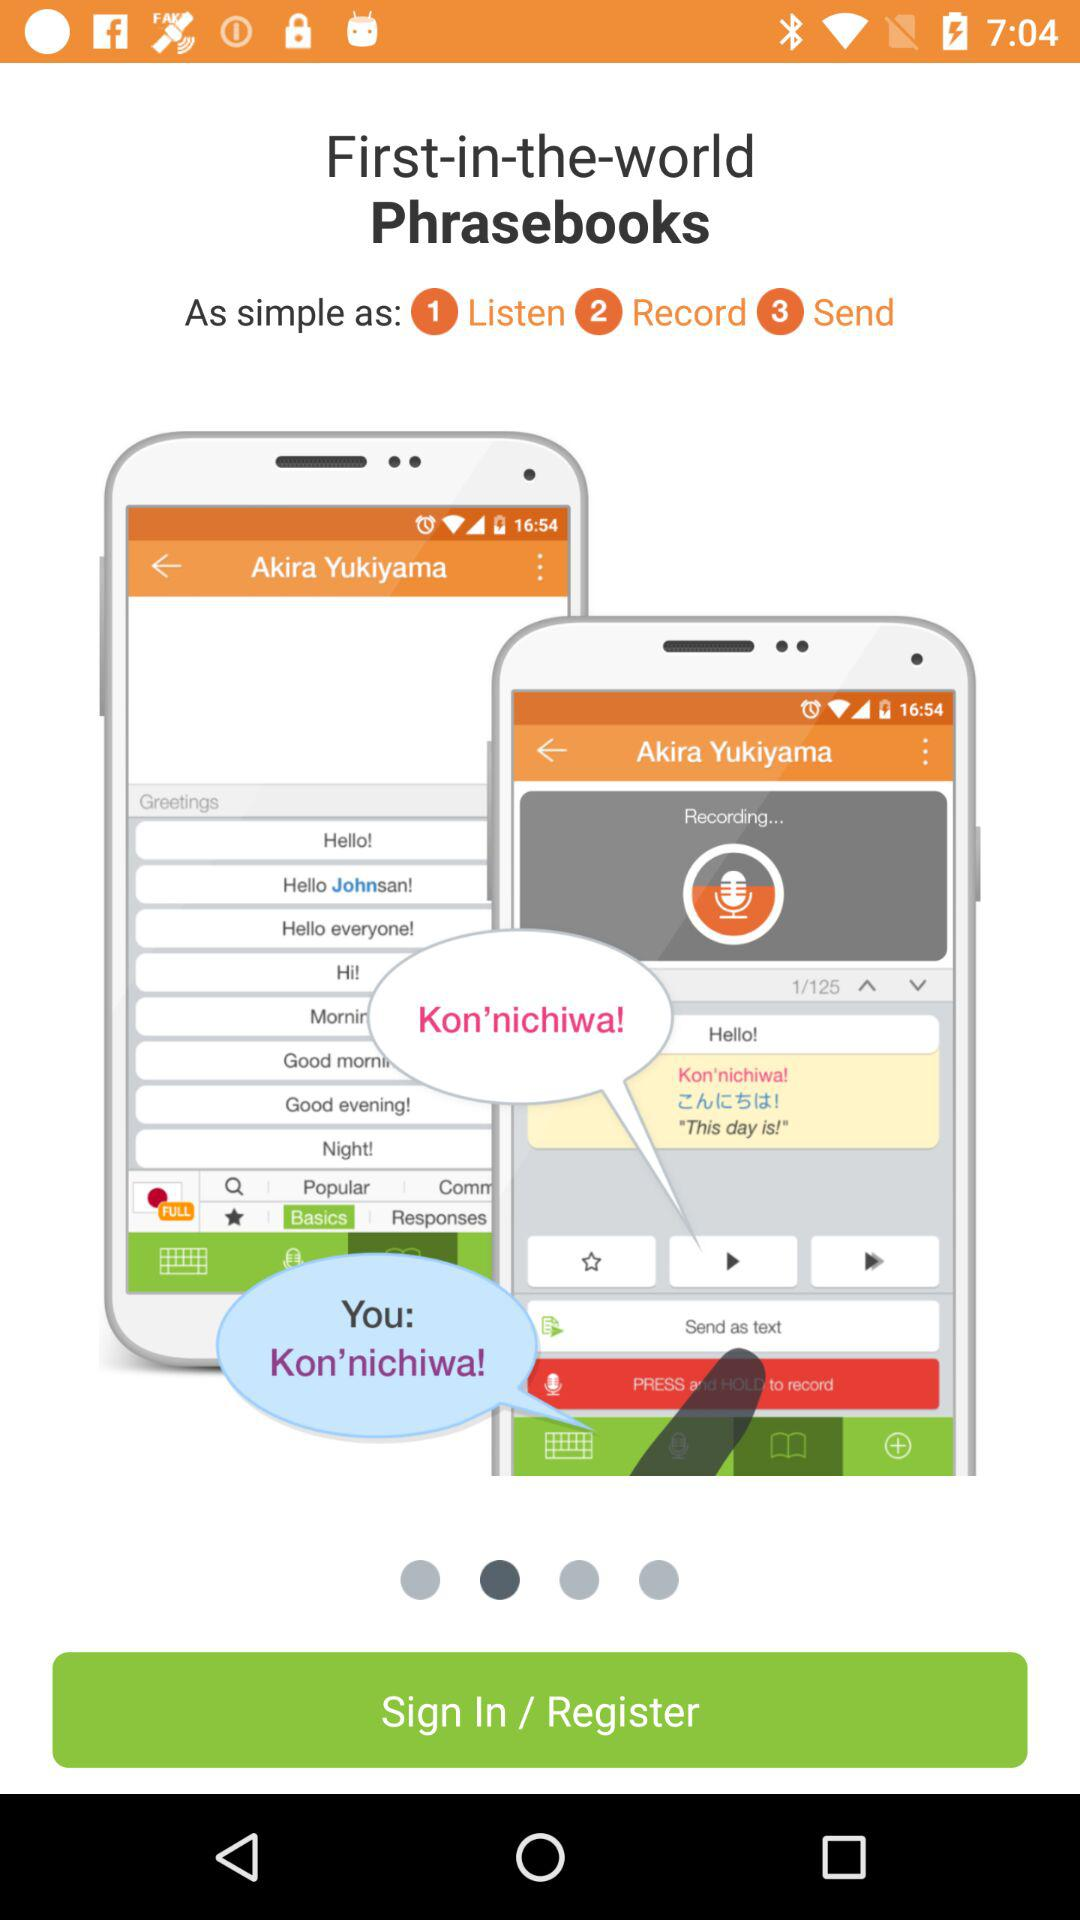Which option is present at step number 1? The option that is present at step number 1 is "Listen". 